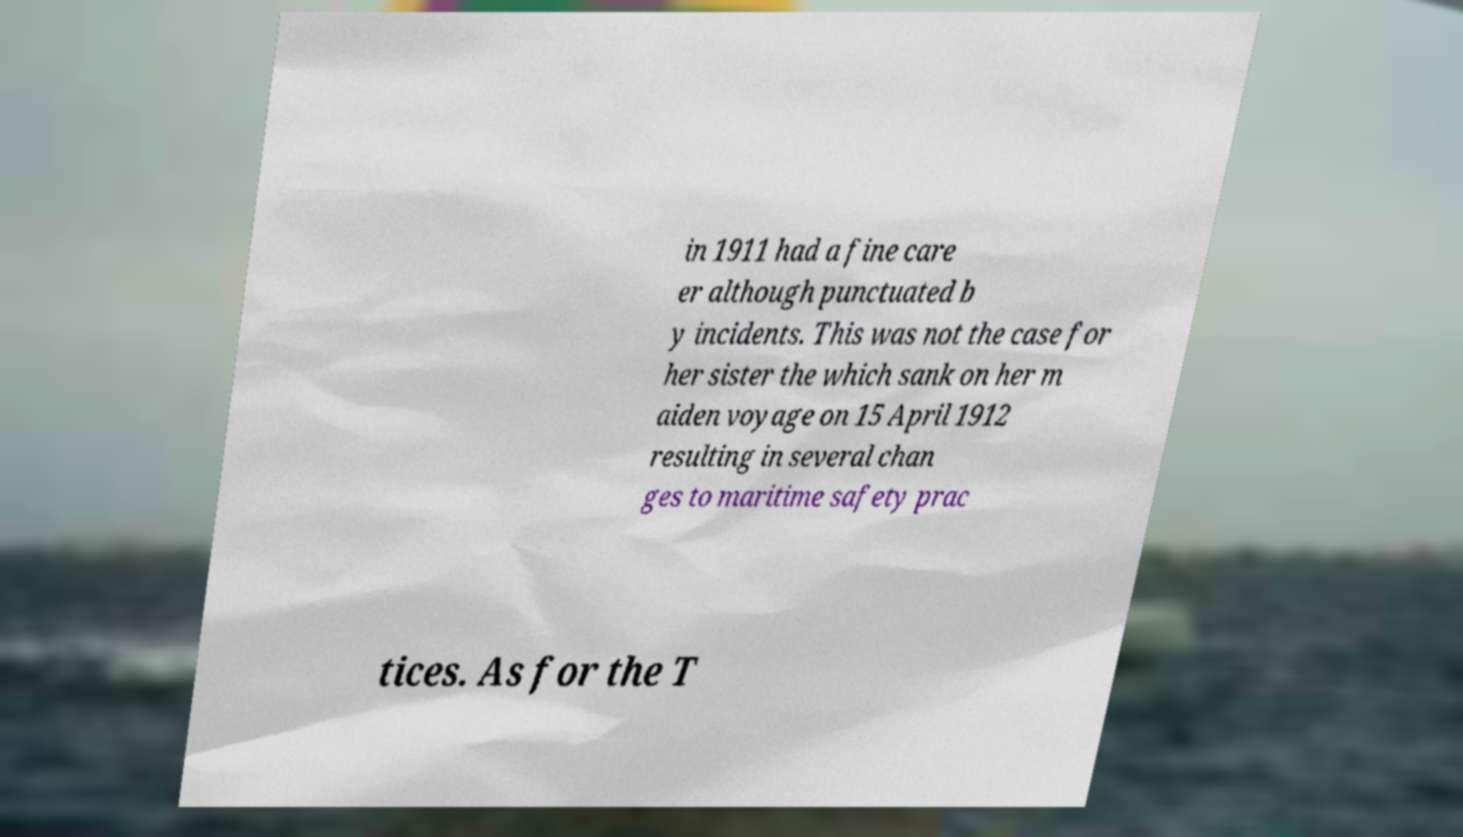Can you read and provide the text displayed in the image?This photo seems to have some interesting text. Can you extract and type it out for me? in 1911 had a fine care er although punctuated b y incidents. This was not the case for her sister the which sank on her m aiden voyage on 15 April 1912 resulting in several chan ges to maritime safety prac tices. As for the T 